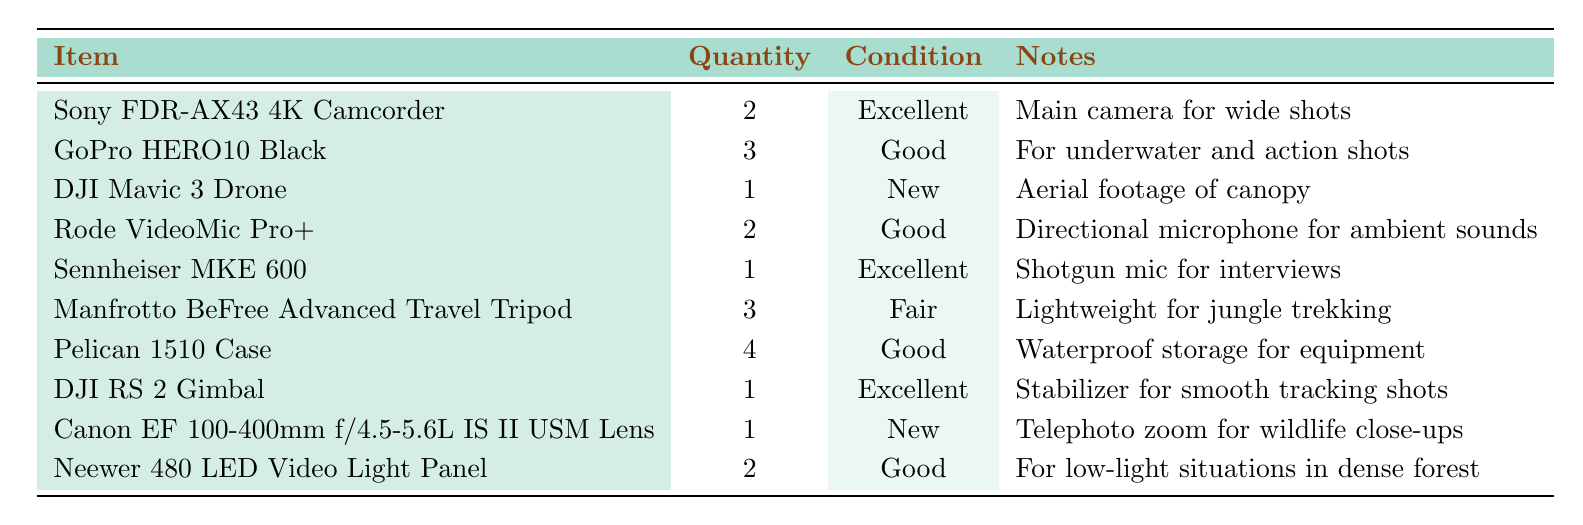What is the quantity of the Sony FDR-AX43 4K Camcorder? The table lists the items and their quantities. For the Sony FDR-AX43 4K Camcorder, the quantity is stated as 2.
Answer: 2 How many items in the inventory are in 'Excellent' condition? The table shows the condition of each item. There are 4 items listed as 'Excellent': Sony FDR-AX43 4K Camcorder, Sennheiser MKE 600, DJI RS 2 Gimbal, and Canon EF 100-400mm f/4.5-5.6L IS II USM Lens.
Answer: 4 What is the total number of GoPro HERO10 Black cameras available? According to the table, the quantity of GoPro HERO10 Black cameras is stated as 3.
Answer: 3 Is the DJI Mavic 3 Drone in 'New' condition? The table states that the DJI Mavic 3 Drone is in 'New' condition, confirming that this statement is true.
Answer: Yes How many items are suitable for low-light situations? The table indicates that there are 2 items for low-light situations: the Neewer 480 LED Video Light Panel, as noted in the 'Notes' column.
Answer: 2 If we add up all the items listed, what is the total quantity of equipment? Sum the quantities of all items: 2 + 3 + 1 + 2 + 1 + 3 + 4 + 1 + 1 + 2 = 20. Therefore, the total quantity is 20.
Answer: 20 What percentage of the total inventory is made up of Pelican 1510 Cases? The total inventory quantity is 20. The number of Pelican 1510 Cases is 4. The percentage is calculated as (4/20) * 100 = 20%.
Answer: 20% Which item has the most quantity available? By examining the table, the Pelican 1510 Case has the highest quantity at 4.
Answer: Pelican 1510 Case Are there more cameras than microphones in the inventory? There are 5 cameras (2 Sony FDR-AX43 + 3 GoPro HERO10 + 1 DJI Mavic 3) and 3 microphones (2 Rode VideoMic Pro+ + 1 Sennheiser MKE 600). Thus, there are more cameras.
Answer: Yes What is the combined quantity of items in 'Good' condition? The table shows 3 items in 'Good' condition (GoPro HERO10 Black, Rode VideoMic Pro+, and Pelican 1510 Case). Their quantities are 3 + 2 + 4 = 9.
Answer: 9 